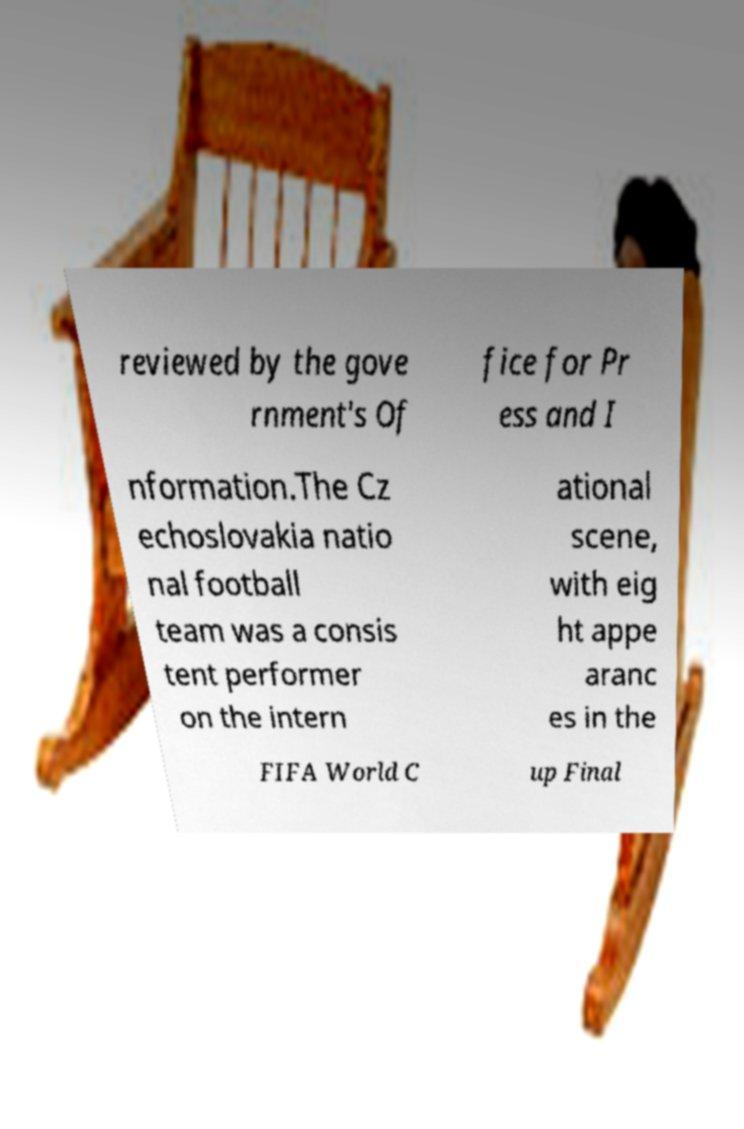For documentation purposes, I need the text within this image transcribed. Could you provide that? reviewed by the gove rnment's Of fice for Pr ess and I nformation.The Cz echoslovakia natio nal football team was a consis tent performer on the intern ational scene, with eig ht appe aranc es in the FIFA World C up Final 